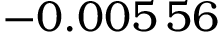<formula> <loc_0><loc_0><loc_500><loc_500>- 0 . 0 0 5 \, 5 6</formula> 